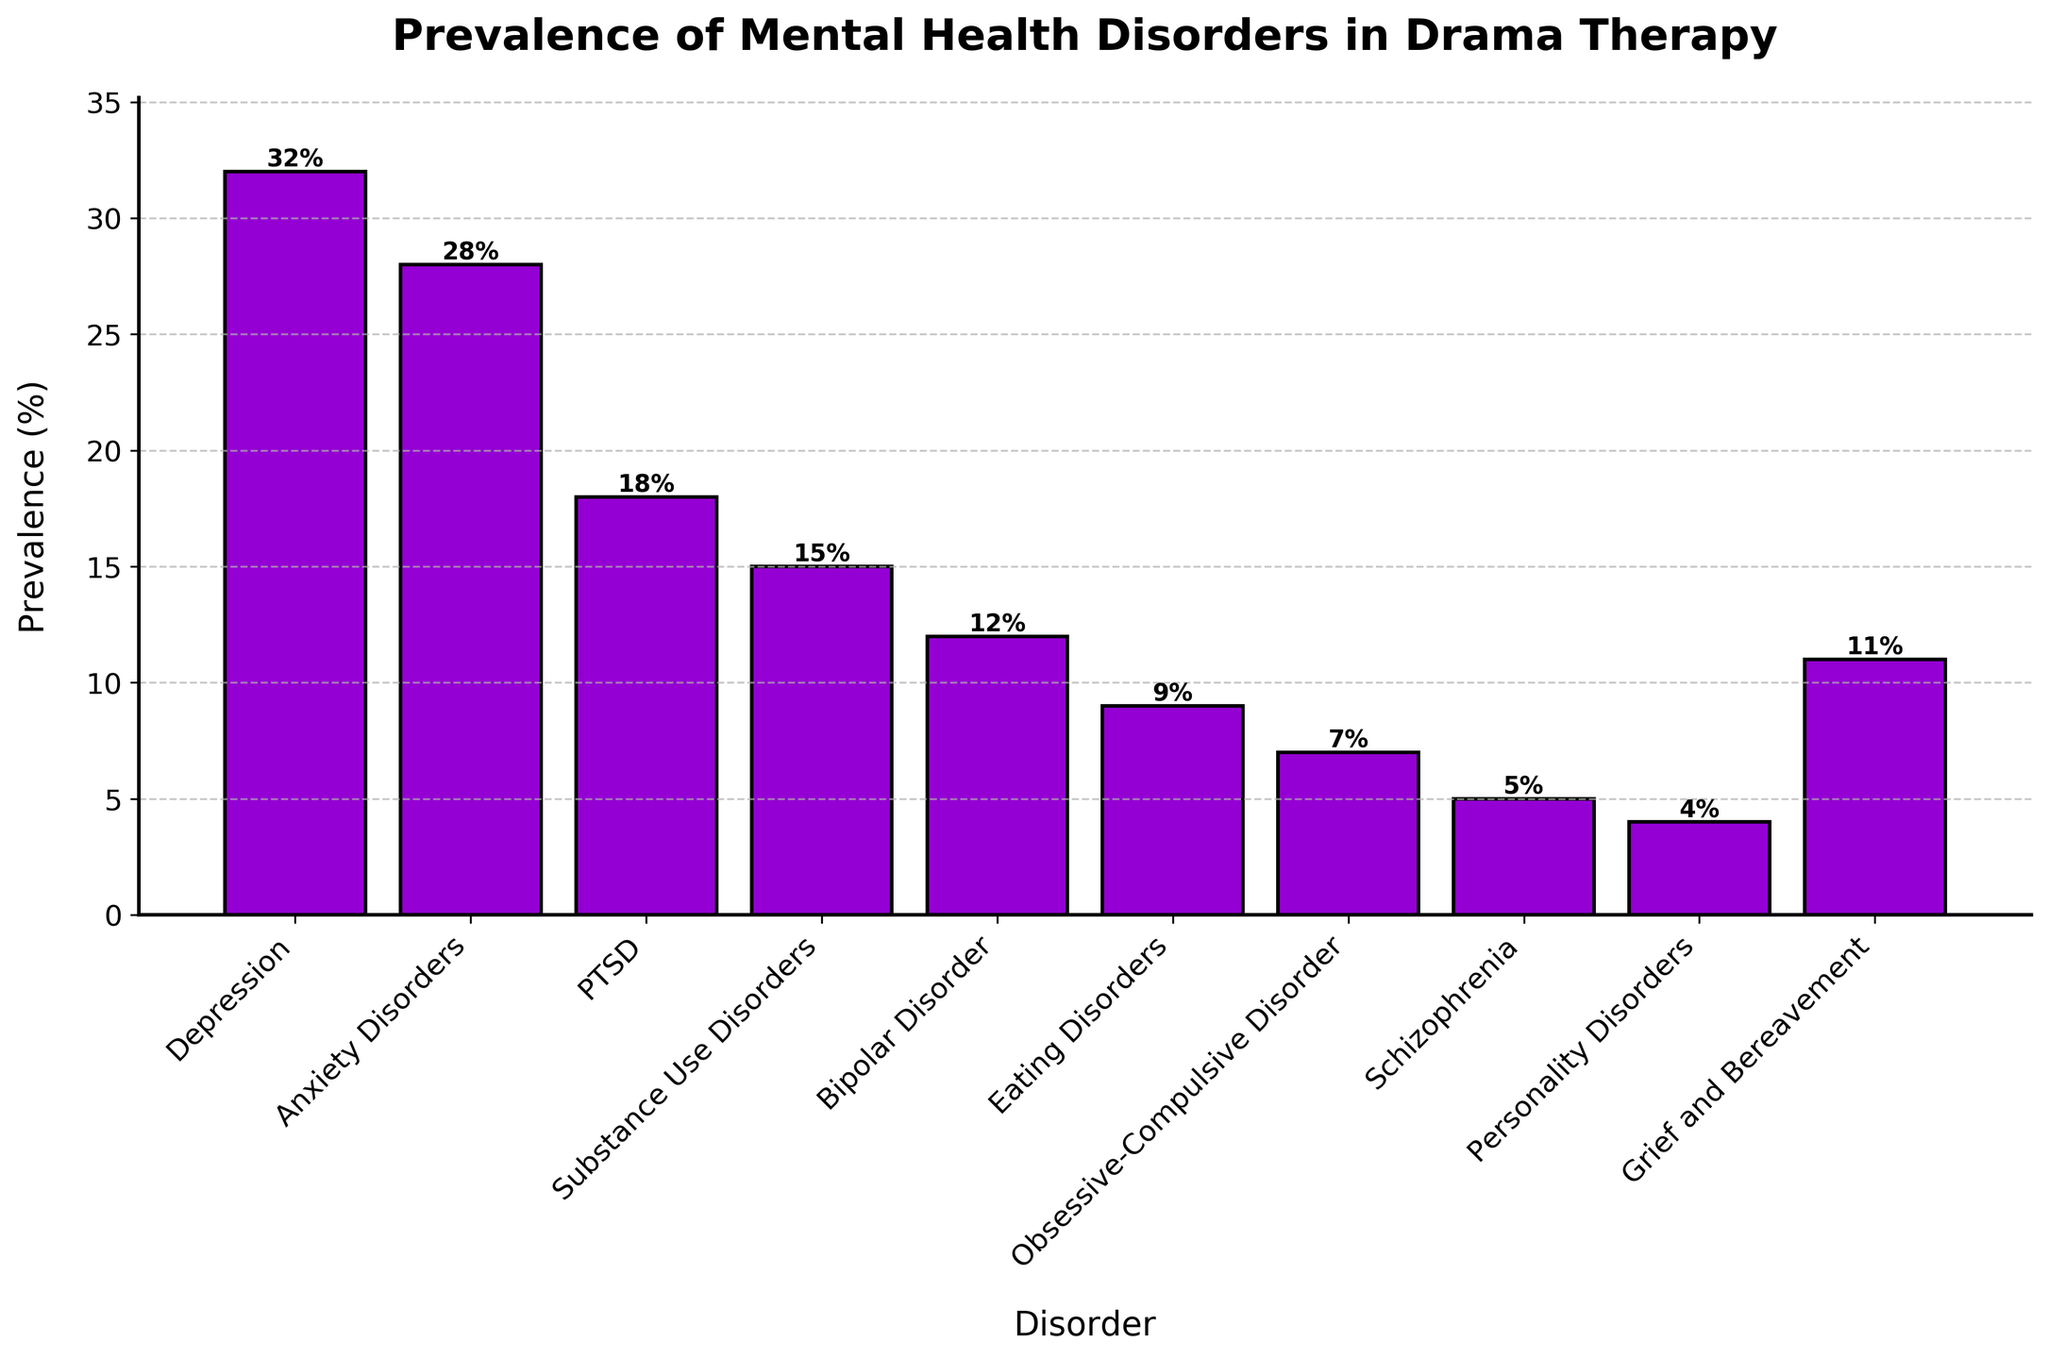What disorder has the highest prevalence in drama therapy? The bar of "Depression" is the tallest compared to other disorders, so it indicates the highest prevalence.
Answer: Depression Which disorder has a higher prevalence, Anxiety Disorders or PTSD? Anxiety Disorders has a bar height of 28%, which is higher than PTSD's bar height of 18%.
Answer: Anxiety Disorders What is the combined prevalence of Substance Use Disorders and Bipolar Disorder? Adding the prevalence of Substance Use Disorders (15%) and Bipolar Disorder (12%) gives 15% + 12% = 27%.
Answer: 27% Does Eating Disorders have a prevalence greater than 10%? The bar for Eating Disorders has a height of 9%, which is less than 10%.
Answer: No Which are the three disorders with the lowest prevalence in drama therapy? The three shortest bars correspond to Personality Disorders (4%), Schizophrenia (5%), and Obsessive-Compulsive Disorder (7%).
Answer: Personality Disorders, Schizophrenia, Obsessive-Compulsive Disorder How much greater is the prevalence of Depression compared to Grief and Bereavement? The prevalence of Depression is 32%, and Grief and Bereavement is 11%. The difference is 32% - 11% = 21%.
Answer: 21% Which disorder has a prevalence almost twice that of Bipolar Disorder? Bipolar Disorder has a prevalence of 12%, and PTSD has a prevalence of 18%, which is close to double (24%) but actually is Anxiety Disorders with 28%.
Answer: Anxiety Disorders What is the average prevalence of Anxiety Disorders, PTSD, and Grief and Bereavement? Adding the prevalence: 28% (Anxiety Disorders) + 18% (PTSD) + 11% (Grief and Bereavement) = 57%. Divide by 3 to get the average: 57% / 3 = 19%.
Answer: 19% Rank the disorders according to prevalence from highest to lowest. The heights of the bars rank the disorders as follows: Depression (32%), Anxiety Disorders (28%), PTSD (18%), Substance Use Disorders (15%), Bipolar Disorder (12%), Grief and Bereavement (11%), Eating Disorders (9%), Obsessive-Compulsive Disorder (7%), Schizophrenia (5%), Personality Disorders (4%).
Answer: Depression, Anxiety Disorders, PTSD, Substance Use Disorders, Bipolar Disorder, Grief and Bereavement, Eating Disorders, Obsessive-Compulsive Disorder, Schizophrenia, Personality Disorders What percentage of disorders have a prevalence less than 10%? There are 10 disorders in total. The disorders with prevalence < 10% are Eating Disorders (9%), Obsessive-Compulsive Disorder (7%), Schizophrenia (5%), and Personality Disorders (4%). That's 4 out of 10 disorders. The calculation: (4/10) * 100% = 40%.
Answer: 40% 